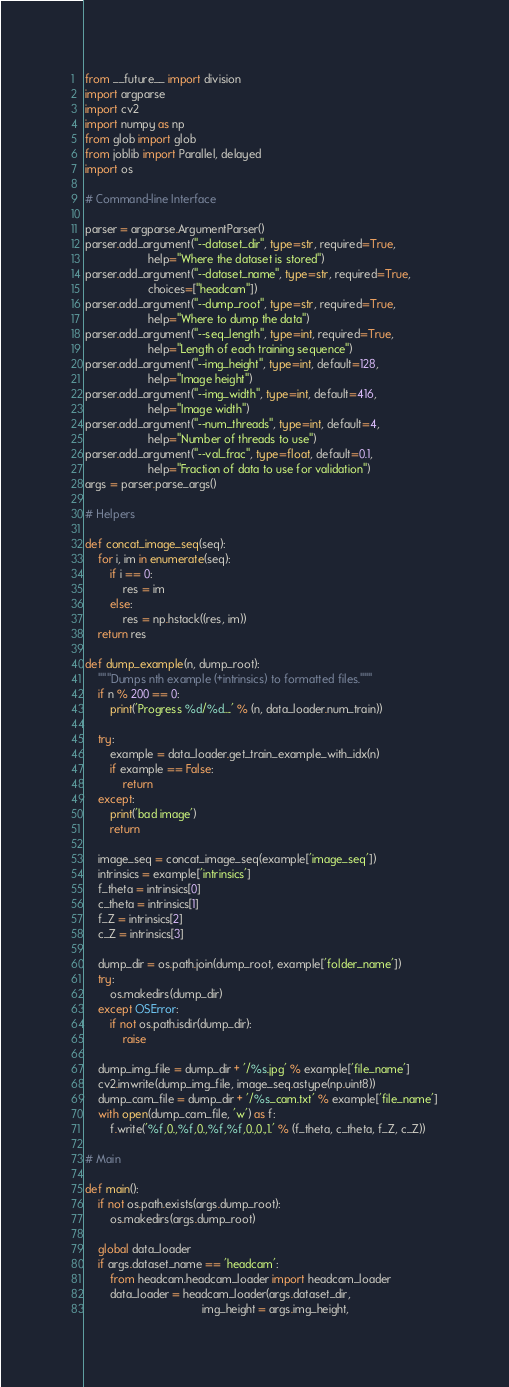Convert code to text. <code><loc_0><loc_0><loc_500><loc_500><_Python_>from __future__ import division
import argparse
import cv2
import numpy as np
from glob import glob
from joblib import Parallel, delayed
import os

# Command-line Interface

parser = argparse.ArgumentParser()
parser.add_argument("--dataset_dir", type=str, required=True,
                    help="Where the dataset is stored")
parser.add_argument("--dataset_name", type=str, required=True,
                    choices=["headcam"])
parser.add_argument("--dump_root", type=str, required=True,
                    help="Where to dump the data")
parser.add_argument("--seq_length", type=int, required=True,
                    help="Length of each training sequence")
parser.add_argument("--img_height", type=int, default=128,
                    help="Image height")
parser.add_argument("--img_width", type=int, default=416,
                    help="Image width")
parser.add_argument("--num_threads", type=int, default=4,
                    help="Number of threads to use")
parser.add_argument("--val_frac", type=float, default=0.1,
                    help="Fraction of data to use for validation")
args = parser.parse_args()

# Helpers

def concat_image_seq(seq):
    for i, im in enumerate(seq):
        if i == 0:
            res = im
        else:
            res = np.hstack((res, im))
    return res

def dump_example(n, dump_root):
    """Dumps nth example (+intrinsics) to formatted files."""
    if n % 200 == 0:
        print('Progress %d/%d....' % (n, data_loader.num_train))

    try:
        example = data_loader.get_train_example_with_idx(n)
        if example == False:
            return
    except:
        print('bad image')
        return

    image_seq = concat_image_seq(example['image_seq'])
    intrinsics = example['intrinsics']
    f_theta = intrinsics[0]
    c_theta = intrinsics[1]
    f_Z = intrinsics[2]
    c_Z = intrinsics[3]

    dump_dir = os.path.join(dump_root, example['folder_name'])
    try:
        os.makedirs(dump_dir)
    except OSError:
        if not os.path.isdir(dump_dir):
            raise

    dump_img_file = dump_dir + '/%s.jpg' % example['file_name']
    cv2.imwrite(dump_img_file, image_seq.astype(np.uint8))
    dump_cam_file = dump_dir + '/%s_cam.txt' % example['file_name']
    with open(dump_cam_file, 'w') as f:
        f.write('%f,0.,%f,0.,%f,%f,0.,0.,1.' % (f_theta, c_theta, f_Z, c_Z))

# Main

def main():
    if not os.path.exists(args.dump_root):
        os.makedirs(args.dump_root)

    global data_loader
    if args.dataset_name == 'headcam':
        from headcam.headcam_loader import headcam_loader
        data_loader = headcam_loader(args.dataset_dir,
                                     img_height = args.img_height,</code> 